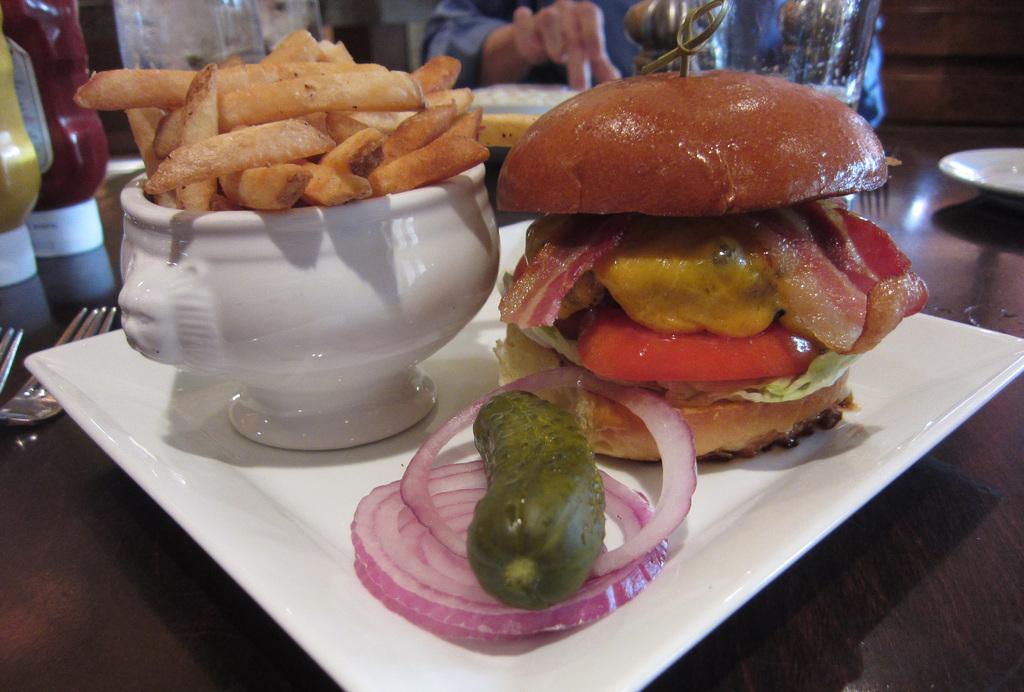Can you describe this image briefly? On the left side there are french fries in a white color bowl, on the right side it looks like a sand witch. In the middle there are onion pieces and a Kheera in a white color plate. 